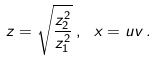<formula> <loc_0><loc_0><loc_500><loc_500>z = \sqrt { \frac { z _ { 2 } ^ { 2 } } { z _ { 1 } ^ { 2 } } } \, , \ x = u v \, .</formula> 